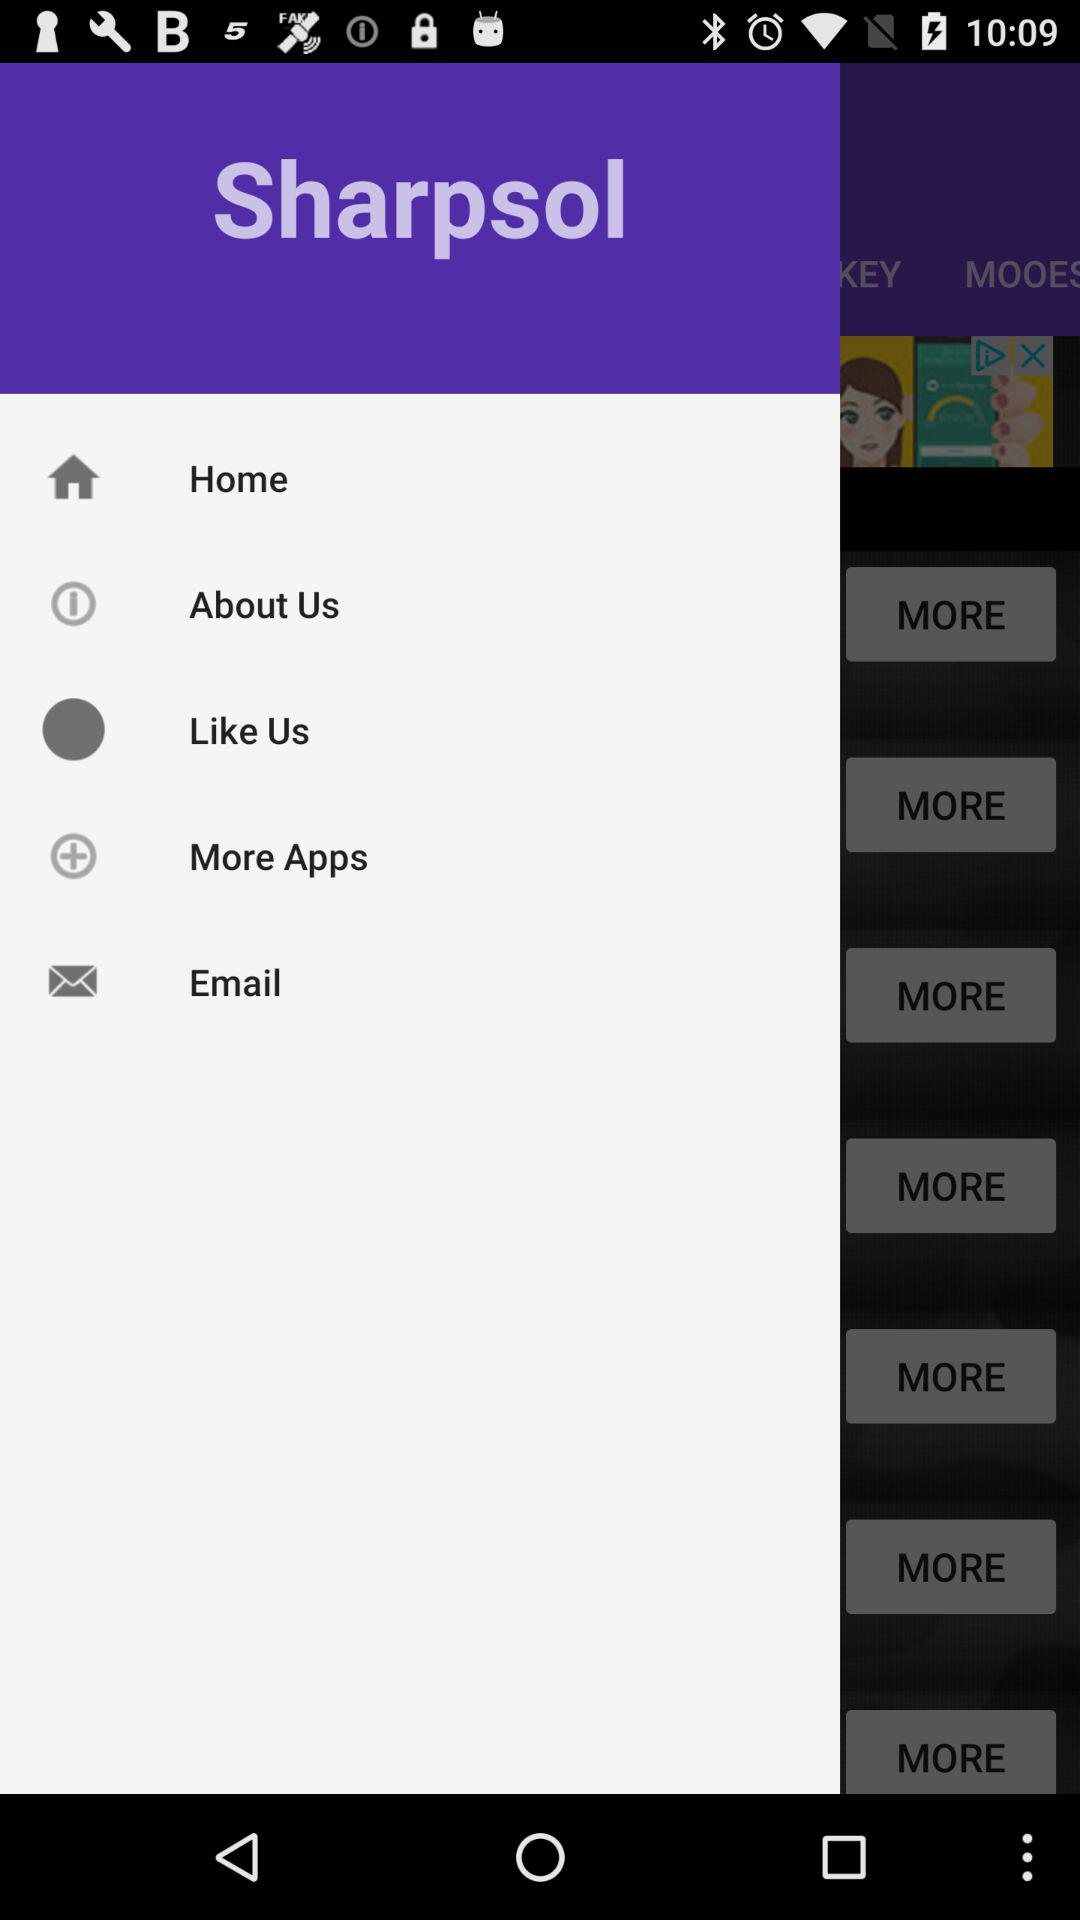What is the name of the application? The name of the application is "Sharpsol". 